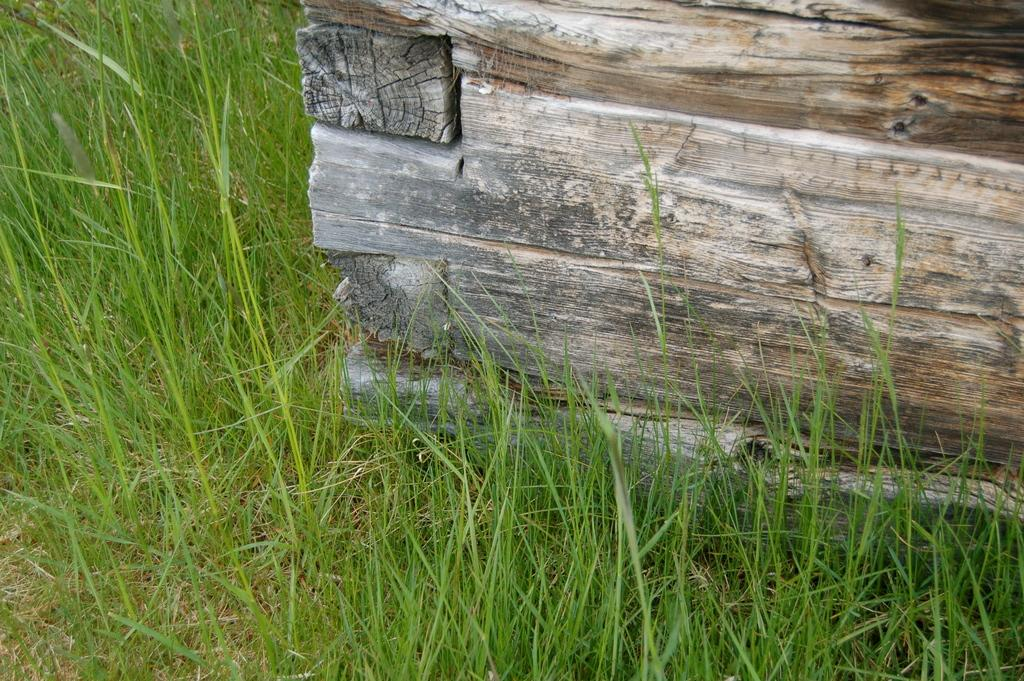What type of material is the object in the image made of? The object in the image is made of wood. What is the ground surface like in the image? The ground in the image is covered with grass. What type of music is the band playing in the image? There is no band present in the image, so it is not possible to determine what type of music they might be playing. 